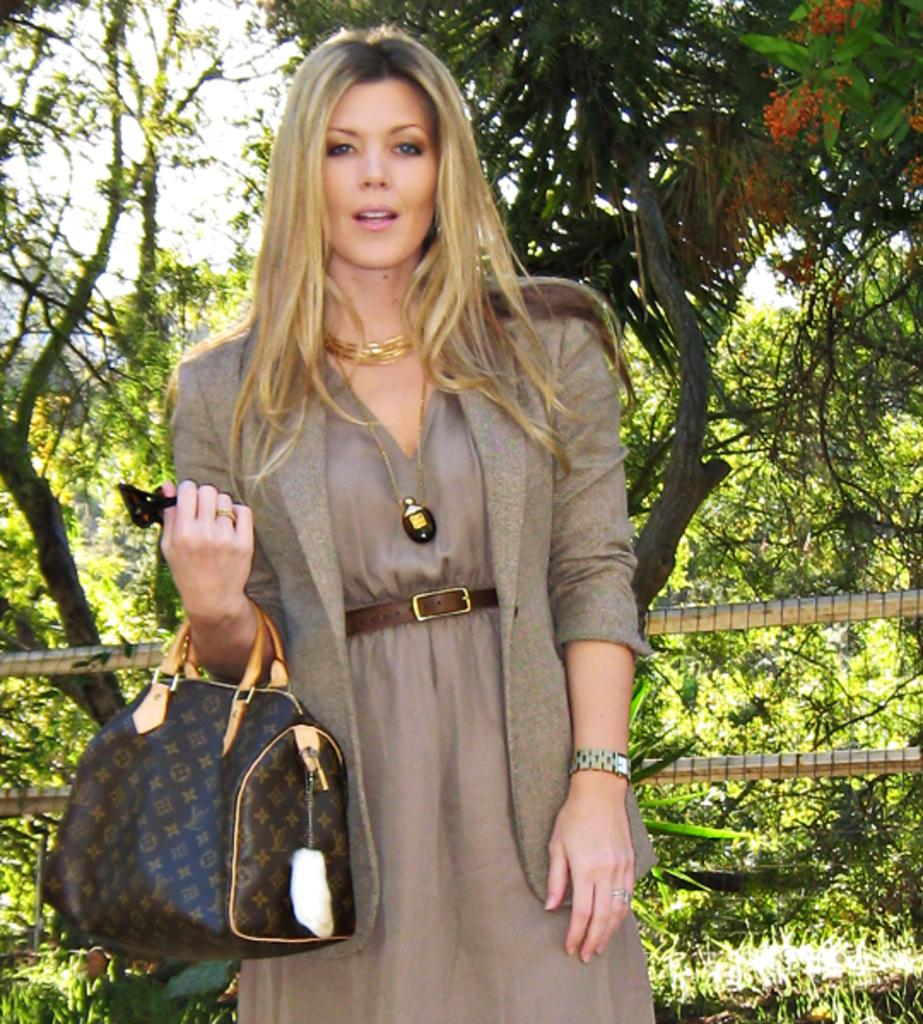What is the main subject of the image? There is a person standing in the image. What is the person holding in the image? The person is holding a bag. What can be seen in the background of the image? There are trees and the sky visible in the background of the image. What type of rock is the person using to hold the bag in the image? There is no rock present in the image; the person is simply holding the bag. Can you tell me how many pickles are visible in the image? There are no pickles present in the image. 